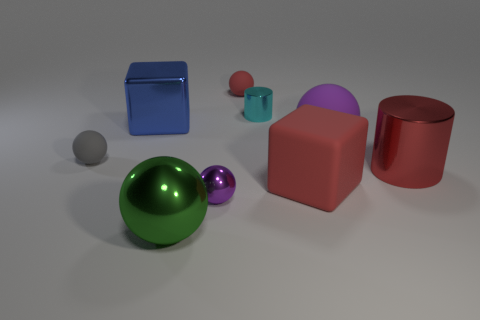Subtract all red spheres. How many spheres are left? 4 Subtract 2 balls. How many balls are left? 3 Subtract all small red matte balls. How many balls are left? 4 Subtract all cyan spheres. Subtract all brown cylinders. How many spheres are left? 5 Subtract all spheres. How many objects are left? 4 Subtract all large spheres. Subtract all big purple matte spheres. How many objects are left? 6 Add 3 big red cylinders. How many big red cylinders are left? 4 Add 7 small cyan metallic spheres. How many small cyan metallic spheres exist? 7 Subtract 0 gray cylinders. How many objects are left? 9 